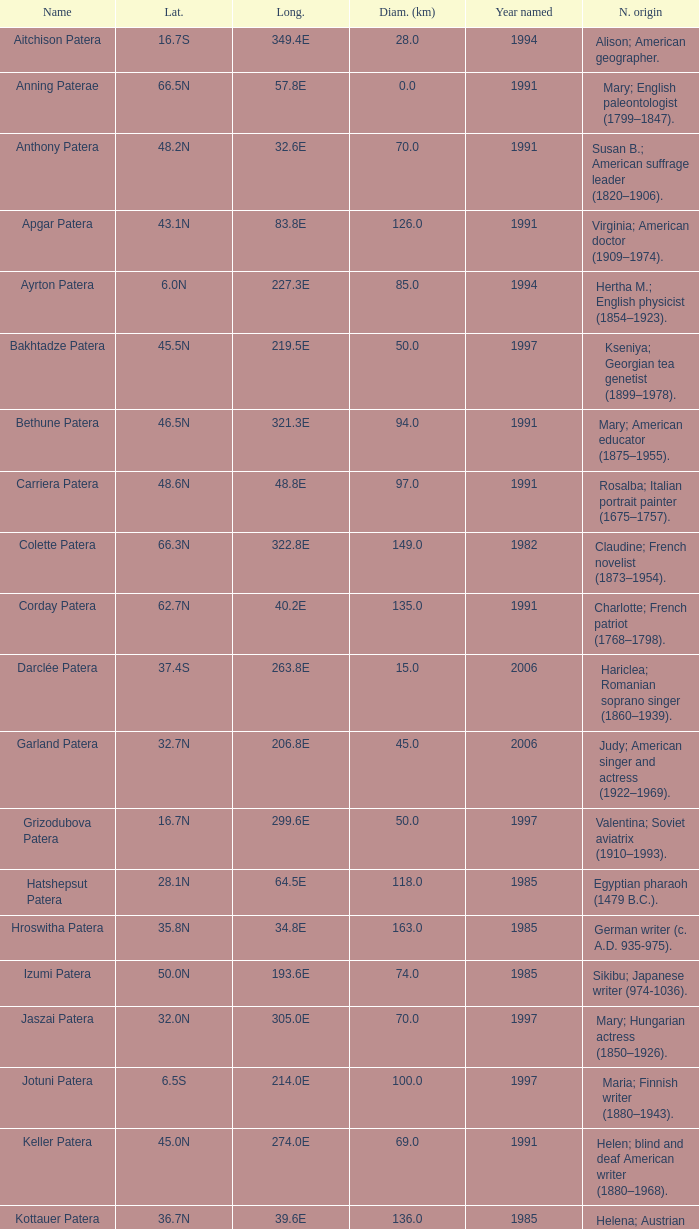What is  the diameter in km of the feature with a longitude of 40.2E?  135.0. 